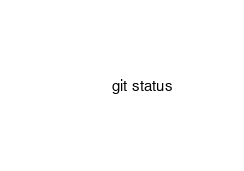<code> <loc_0><loc_0><loc_500><loc_500><_Bash_>git status
</code> 